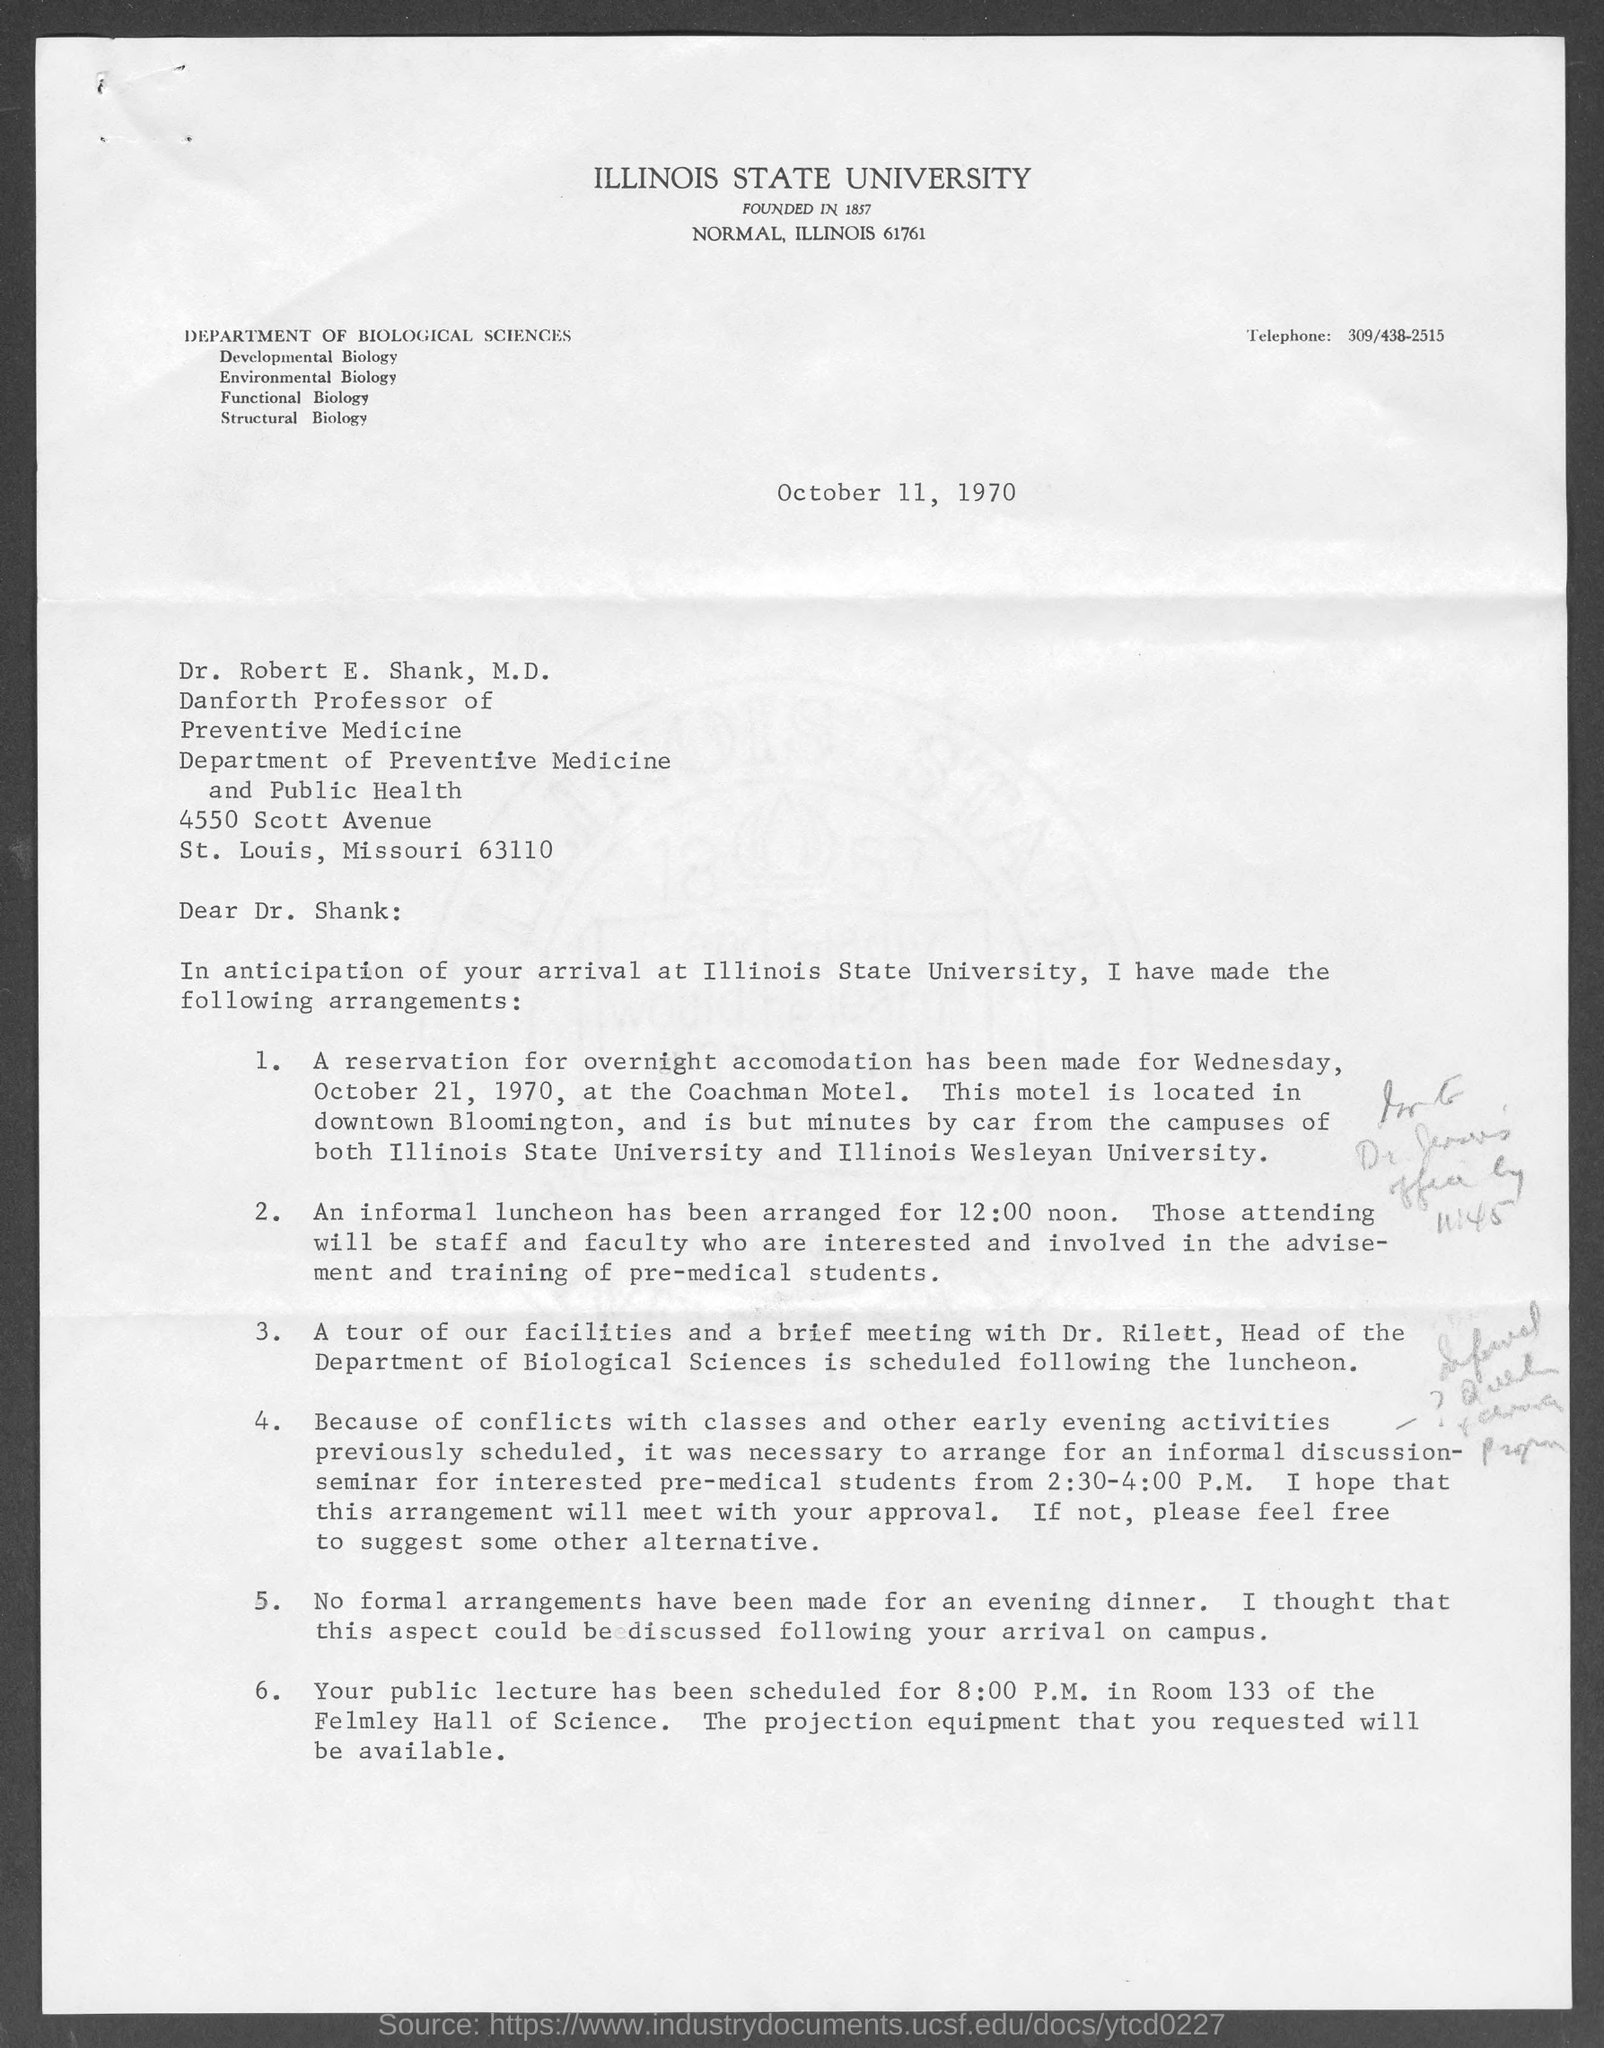What is the date mentioned in the top of the document ?
Keep it short and to the point. October 11, 1970. What is the Telephone Number?
Offer a terse response. 309/438-2515. 